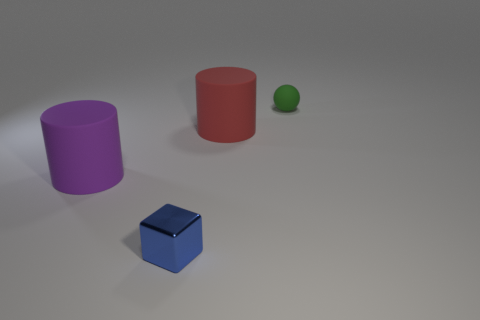What shape is the green thing that is the same size as the blue metal cube? sphere 